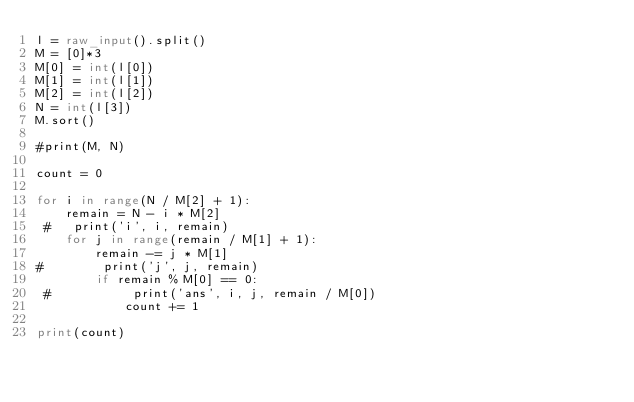<code> <loc_0><loc_0><loc_500><loc_500><_Python_>l = raw_input().split()
M = [0]*3
M[0] = int(l[0])
M[1] = int(l[1])
M[2] = int(l[2])
N = int(l[3])
M.sort()

#print(M, N)

count = 0

for i in range(N / M[2] + 1):
    remain = N - i * M[2]
 #   print('i', i, remain)
    for j in range(remain / M[1] + 1):
        remain -= j * M[1]
#        print('j', j, remain)
        if remain % M[0] == 0:
 #           print('ans', i, j, remain / M[0])
            count += 1

print(count)

</code> 